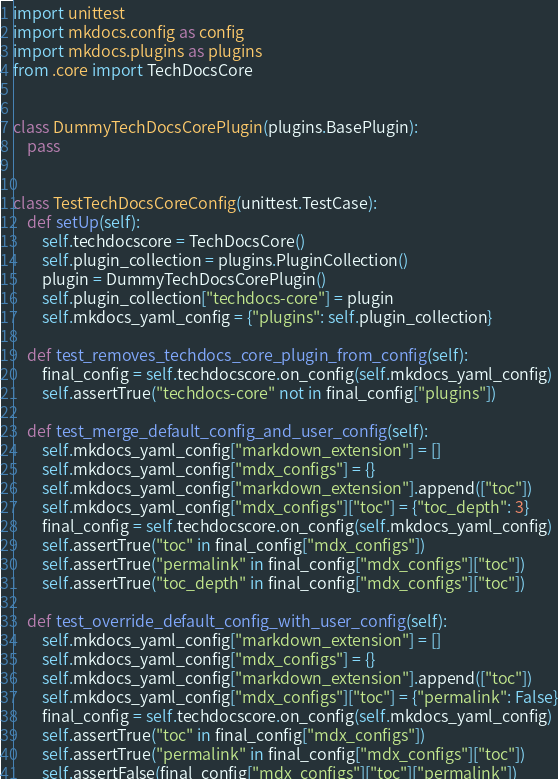<code> <loc_0><loc_0><loc_500><loc_500><_Python_>import unittest
import mkdocs.config as config
import mkdocs.plugins as plugins
from .core import TechDocsCore


class DummyTechDocsCorePlugin(plugins.BasePlugin):
    pass


class TestTechDocsCoreConfig(unittest.TestCase):
    def setUp(self):
        self.techdocscore = TechDocsCore()
        self.plugin_collection = plugins.PluginCollection()
        plugin = DummyTechDocsCorePlugin()
        self.plugin_collection["techdocs-core"] = plugin
        self.mkdocs_yaml_config = {"plugins": self.plugin_collection}

    def test_removes_techdocs_core_plugin_from_config(self):
        final_config = self.techdocscore.on_config(self.mkdocs_yaml_config)
        self.assertTrue("techdocs-core" not in final_config["plugins"])

    def test_merge_default_config_and_user_config(self):
        self.mkdocs_yaml_config["markdown_extension"] = []
        self.mkdocs_yaml_config["mdx_configs"] = {}
        self.mkdocs_yaml_config["markdown_extension"].append(["toc"])
        self.mkdocs_yaml_config["mdx_configs"]["toc"] = {"toc_depth": 3}
        final_config = self.techdocscore.on_config(self.mkdocs_yaml_config)
        self.assertTrue("toc" in final_config["mdx_configs"])
        self.assertTrue("permalink" in final_config["mdx_configs"]["toc"])
        self.assertTrue("toc_depth" in final_config["mdx_configs"]["toc"])

    def test_override_default_config_with_user_config(self):
        self.mkdocs_yaml_config["markdown_extension"] = []
        self.mkdocs_yaml_config["mdx_configs"] = {}
        self.mkdocs_yaml_config["markdown_extension"].append(["toc"])
        self.mkdocs_yaml_config["mdx_configs"]["toc"] = {"permalink": False}
        final_config = self.techdocscore.on_config(self.mkdocs_yaml_config)
        self.assertTrue("toc" in final_config["mdx_configs"])
        self.assertTrue("permalink" in final_config["mdx_configs"]["toc"])
        self.assertFalse(final_config["mdx_configs"]["toc"]["permalink"])
</code> 